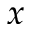<formula> <loc_0><loc_0><loc_500><loc_500>x</formula> 